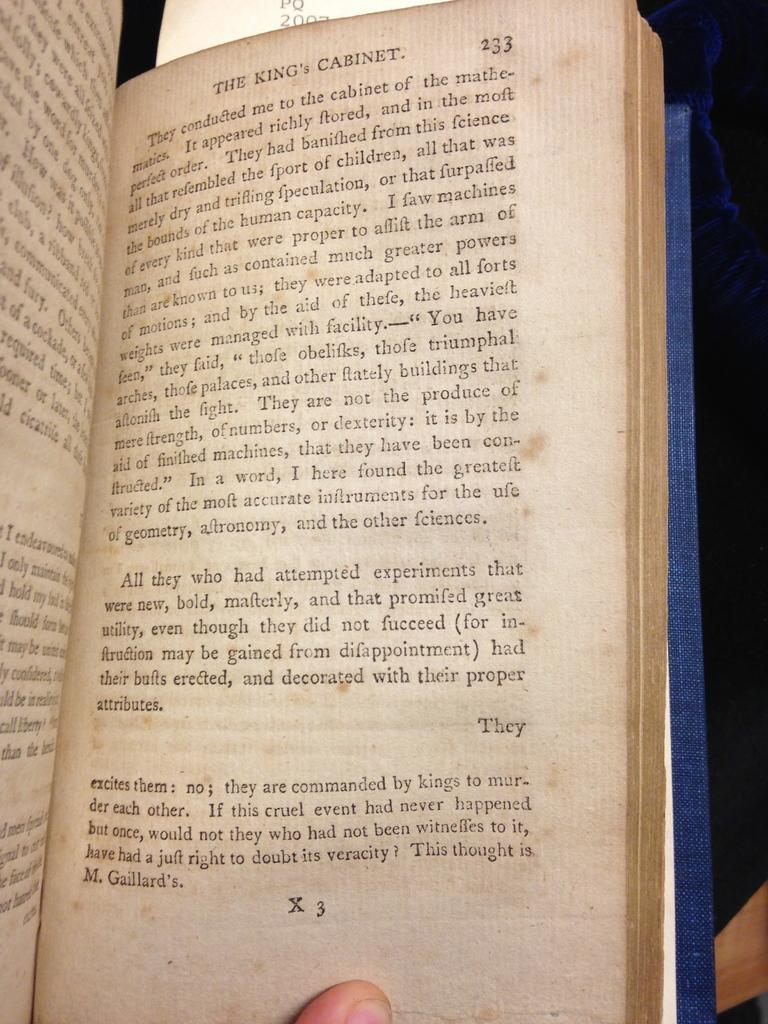Provide a one-sentence caption for the provided image. Page 233 is open of the book called The King's Cabinet. 